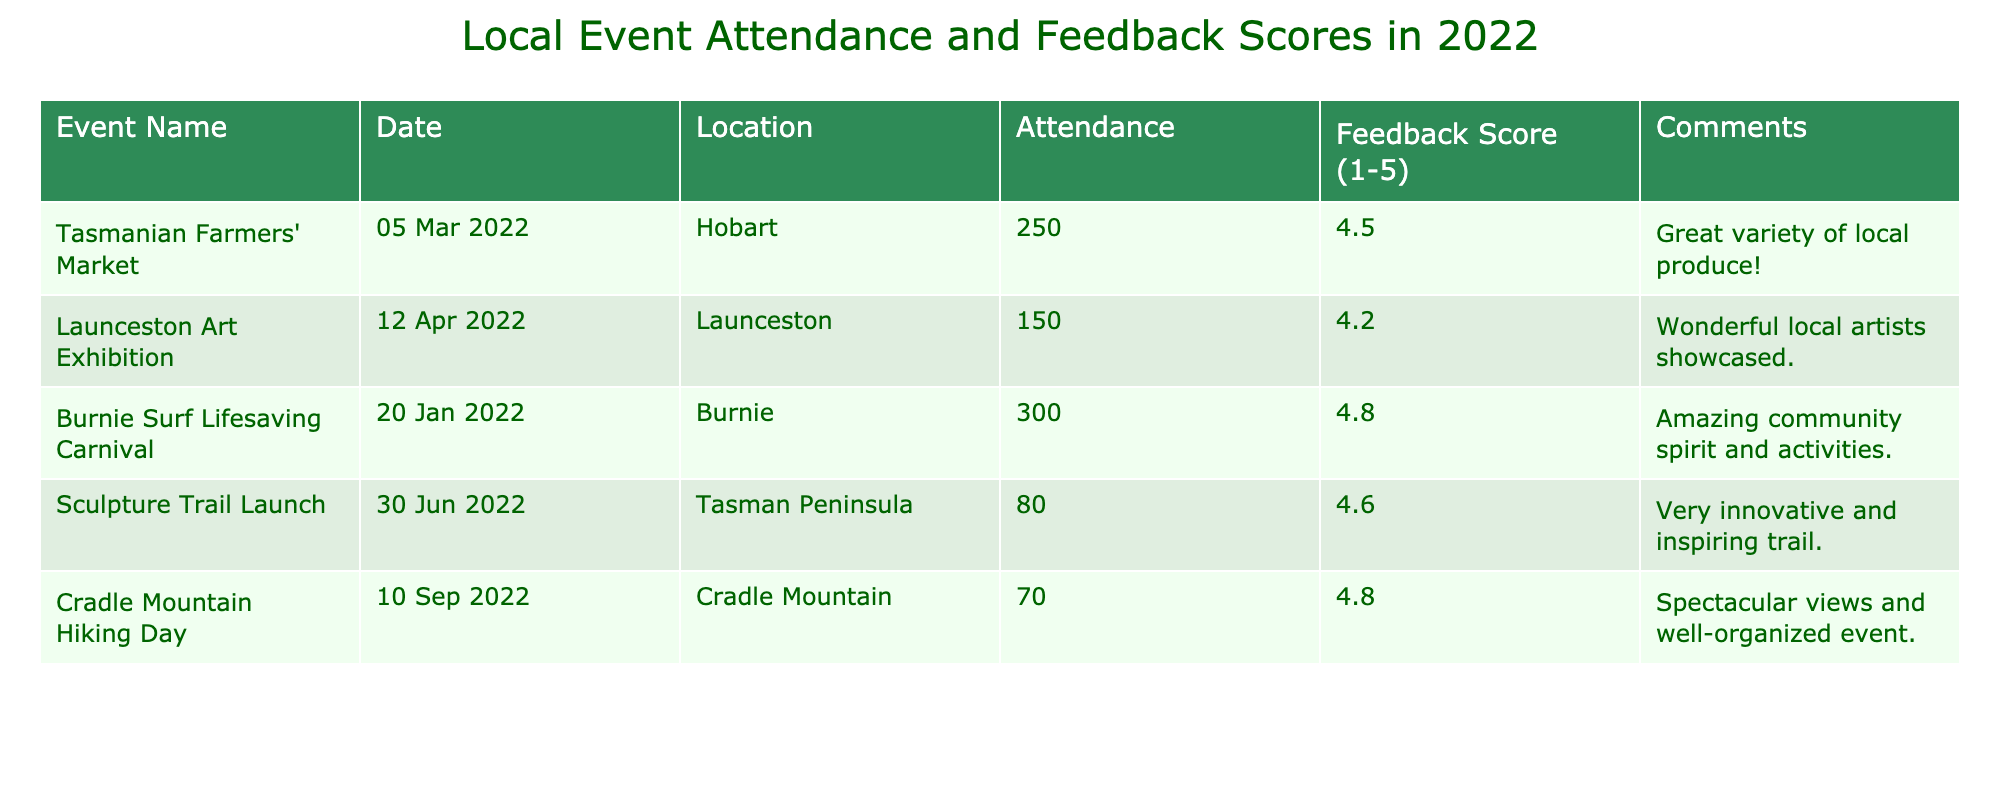What is the total attendance for all events listed? To find the total attendance, sum the attendance numbers for each event: 250 + 150 + 300 + 80 + 70 = 850.
Answer: 850 Which event had the highest feedback score? The feedback scores for the events are compared, and the highest score is 4.8 from the Burnie Surf Lifesaving Carnival and the Cradle Mountain Hiking Day.
Answer: Burnie Surf Lifesaving Carnival and Cradle Mountain Hiking Day How many events had a feedback score of 4.5 or higher? The events with scores of 4.5 or higher are: Tasmanian Farmers' Market (4.5), Burnie Surf Lifesaving Carnival (4.8), Sculpture Trail Launch (4.6), and Cradle Mountain Hiking Day (4.8). That's a total of 4 events.
Answer: 4 What is the average feedback score of all events? The feedback scores are 4.5, 4.2, 4.8, 4.6, and 4.8. Adding these gives 4.5 + 4.2 + 4.8 + 4.6 + 4.8 = 24. The average is 24 divided by 5, which equals 4.8.
Answer: 4.8 Did any of the events have an attendance of less than 100? Checking the attendance for each event shows that all attendance numbers are 70 or above, with the lowest being 70. Thus, no events had attendance under 100.
Answer: No What is the difference in attendance between the highest and lowest attended events? The highest attendance is 300 (Burnie Surf Lifesaving Carnival) and the lowest is 70 (Cradle Mountain Hiking Day). The difference is 300 - 70 = 230.
Answer: 230 How many events were held in Hobart? The only event listed that took place in Hobart is the Tasmanian Farmers' Market. Hence, the total count is 1.
Answer: 1 Was the Sculpture Trail Launch rated as the best event based on feedback score? No, the highest feedback score was 4.8. The Sculpture Trail Launch received a score of 4.6, which is not the highest.
Answer: No Which month had the most events? Reviewing the dates, March (1 event), April (1 event), January (1 event), June (1 event), and September (1 event) all have one event each. Thus, all months are tied with 1 event.
Answer: None, all months had the same number of events 